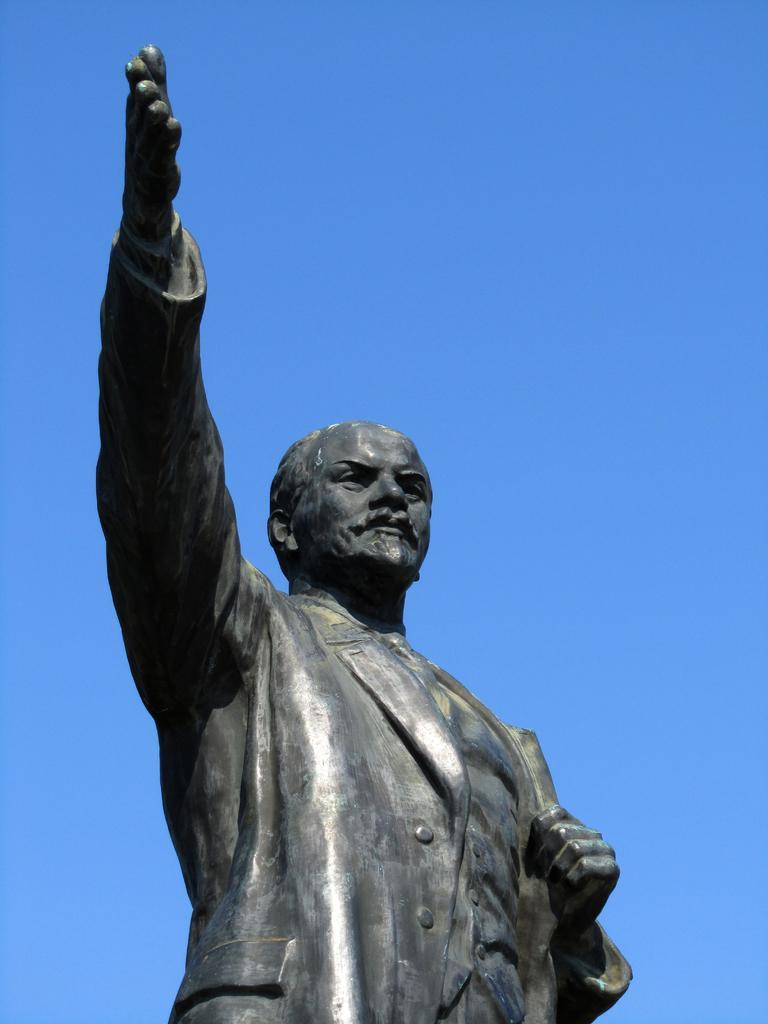Please provide a concise description of this image. There is a person's statue. In the background, there is blue sky. 